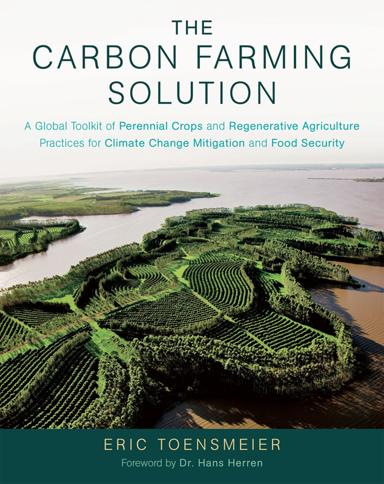What is the title of the book mentioned in the image? The book shown in the image is titled "The Carbon Farming Solution: A Global Toolkit of Perennial Crops and Regenerative Agriculture Practices for Climate Change Mitigation and Food Security." Authored by Eric Toensmeier, it delves into sustainable agricultural practices that can aid in mitigating climate change and enhancing food security. 